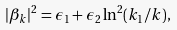<formula> <loc_0><loc_0><loc_500><loc_500>| \beta _ { k } | ^ { 2 } = \epsilon _ { 1 } + \epsilon _ { 2 } \ln ^ { 2 } ( { k _ { 1 } / k } ) ,</formula> 